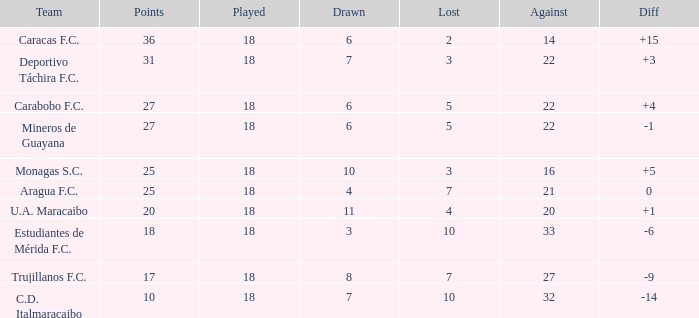What is the sum of the points of all teams that had against scores less than 14? None. 